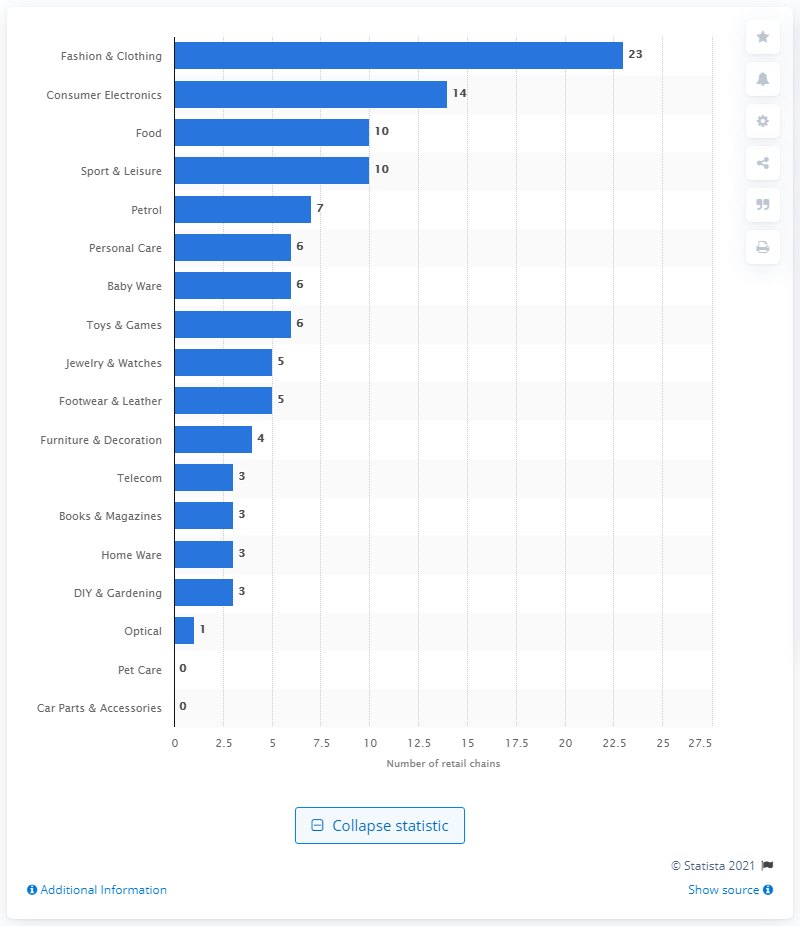Indicate a few pertinent items in this graphic. There were 14 retail chains in the consumer electronics market in Serbia in the year 2020. 